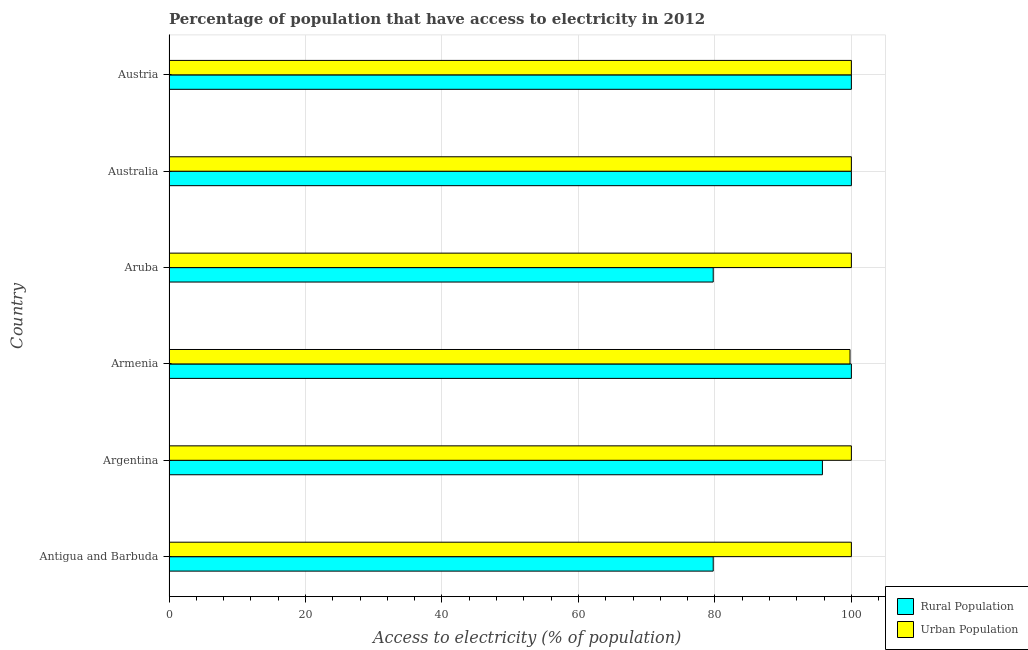Are the number of bars per tick equal to the number of legend labels?
Offer a very short reply. Yes. Are the number of bars on each tick of the Y-axis equal?
Keep it short and to the point. Yes. How many bars are there on the 1st tick from the bottom?
Make the answer very short. 2. What is the label of the 6th group of bars from the top?
Provide a short and direct response. Antigua and Barbuda. In how many cases, is the number of bars for a given country not equal to the number of legend labels?
Your answer should be very brief. 0. What is the percentage of rural population having access to electricity in Antigua and Barbuda?
Provide a succinct answer. 79.75. Across all countries, what is the maximum percentage of urban population having access to electricity?
Your response must be concise. 100. Across all countries, what is the minimum percentage of urban population having access to electricity?
Offer a very short reply. 99.8. In which country was the percentage of rural population having access to electricity maximum?
Provide a succinct answer. Armenia. In which country was the percentage of urban population having access to electricity minimum?
Offer a very short reply. Armenia. What is the total percentage of rural population having access to electricity in the graph?
Provide a short and direct response. 555.26. What is the difference between the percentage of rural population having access to electricity in Antigua and Barbuda and that in Aruba?
Provide a succinct answer. 0. What is the difference between the percentage of urban population having access to electricity in Argentina and the percentage of rural population having access to electricity in Austria?
Give a very brief answer. 0. What is the average percentage of urban population having access to electricity per country?
Offer a terse response. 99.97. What is the difference between the percentage of urban population having access to electricity and percentage of rural population having access to electricity in Antigua and Barbuda?
Your answer should be very brief. 20.25. In how many countries, is the percentage of urban population having access to electricity greater than 40 %?
Offer a terse response. 6. What is the ratio of the percentage of rural population having access to electricity in Aruba to that in Australia?
Provide a succinct answer. 0.8. Is the difference between the percentage of rural population having access to electricity in Aruba and Australia greater than the difference between the percentage of urban population having access to electricity in Aruba and Australia?
Your answer should be compact. No. What is the difference between the highest and the second highest percentage of urban population having access to electricity?
Your answer should be compact. 0. What is the difference between the highest and the lowest percentage of urban population having access to electricity?
Provide a succinct answer. 0.2. What does the 1st bar from the top in Austria represents?
Give a very brief answer. Urban Population. What does the 1st bar from the bottom in Austria represents?
Make the answer very short. Rural Population. Are all the bars in the graph horizontal?
Your answer should be very brief. Yes. What is the difference between two consecutive major ticks on the X-axis?
Provide a succinct answer. 20. Does the graph contain grids?
Your answer should be very brief. Yes. Where does the legend appear in the graph?
Give a very brief answer. Bottom right. How are the legend labels stacked?
Offer a very short reply. Vertical. What is the title of the graph?
Keep it short and to the point. Percentage of population that have access to electricity in 2012. Does "Males" appear as one of the legend labels in the graph?
Provide a succinct answer. No. What is the label or title of the X-axis?
Your answer should be compact. Access to electricity (% of population). What is the label or title of the Y-axis?
Provide a succinct answer. Country. What is the Access to electricity (% of population) in Rural Population in Antigua and Barbuda?
Your answer should be compact. 79.75. What is the Access to electricity (% of population) in Rural Population in Argentina?
Offer a very short reply. 95.75. What is the Access to electricity (% of population) of Urban Population in Armenia?
Your response must be concise. 99.8. What is the Access to electricity (% of population) of Rural Population in Aruba?
Offer a very short reply. 79.75. What is the Access to electricity (% of population) in Urban Population in Aruba?
Keep it short and to the point. 100. What is the Access to electricity (% of population) of Urban Population in Australia?
Make the answer very short. 100. What is the Access to electricity (% of population) of Rural Population in Austria?
Provide a succinct answer. 100. What is the Access to electricity (% of population) in Urban Population in Austria?
Your answer should be compact. 100. Across all countries, what is the minimum Access to electricity (% of population) in Rural Population?
Provide a succinct answer. 79.75. Across all countries, what is the minimum Access to electricity (% of population) of Urban Population?
Provide a succinct answer. 99.8. What is the total Access to electricity (% of population) of Rural Population in the graph?
Offer a terse response. 555.26. What is the total Access to electricity (% of population) in Urban Population in the graph?
Keep it short and to the point. 599.8. What is the difference between the Access to electricity (% of population) of Urban Population in Antigua and Barbuda and that in Argentina?
Provide a short and direct response. 0. What is the difference between the Access to electricity (% of population) of Rural Population in Antigua and Barbuda and that in Armenia?
Your response must be concise. -20.25. What is the difference between the Access to electricity (% of population) in Urban Population in Antigua and Barbuda and that in Aruba?
Provide a succinct answer. 0. What is the difference between the Access to electricity (% of population) of Rural Population in Antigua and Barbuda and that in Australia?
Provide a short and direct response. -20.25. What is the difference between the Access to electricity (% of population) of Urban Population in Antigua and Barbuda and that in Australia?
Give a very brief answer. 0. What is the difference between the Access to electricity (% of population) of Rural Population in Antigua and Barbuda and that in Austria?
Your response must be concise. -20.25. What is the difference between the Access to electricity (% of population) of Urban Population in Antigua and Barbuda and that in Austria?
Offer a terse response. 0. What is the difference between the Access to electricity (% of population) in Rural Population in Argentina and that in Armenia?
Your response must be concise. -4.25. What is the difference between the Access to electricity (% of population) in Urban Population in Argentina and that in Armenia?
Provide a short and direct response. 0.2. What is the difference between the Access to electricity (% of population) in Rural Population in Argentina and that in Australia?
Provide a short and direct response. -4.25. What is the difference between the Access to electricity (% of population) in Urban Population in Argentina and that in Australia?
Offer a terse response. 0. What is the difference between the Access to electricity (% of population) in Rural Population in Argentina and that in Austria?
Your answer should be very brief. -4.25. What is the difference between the Access to electricity (% of population) of Rural Population in Armenia and that in Aruba?
Provide a succinct answer. 20.25. What is the difference between the Access to electricity (% of population) of Urban Population in Armenia and that in Aruba?
Your response must be concise. -0.2. What is the difference between the Access to electricity (% of population) in Rural Population in Armenia and that in Australia?
Keep it short and to the point. 0. What is the difference between the Access to electricity (% of population) in Urban Population in Armenia and that in Australia?
Provide a short and direct response. -0.2. What is the difference between the Access to electricity (% of population) of Rural Population in Armenia and that in Austria?
Your answer should be very brief. 0. What is the difference between the Access to electricity (% of population) of Urban Population in Armenia and that in Austria?
Your answer should be very brief. -0.2. What is the difference between the Access to electricity (% of population) of Rural Population in Aruba and that in Australia?
Provide a short and direct response. -20.25. What is the difference between the Access to electricity (% of population) in Rural Population in Aruba and that in Austria?
Ensure brevity in your answer.  -20.25. What is the difference between the Access to electricity (% of population) of Rural Population in Antigua and Barbuda and the Access to electricity (% of population) of Urban Population in Argentina?
Offer a very short reply. -20.25. What is the difference between the Access to electricity (% of population) of Rural Population in Antigua and Barbuda and the Access to electricity (% of population) of Urban Population in Armenia?
Your answer should be very brief. -20.05. What is the difference between the Access to electricity (% of population) in Rural Population in Antigua and Barbuda and the Access to electricity (% of population) in Urban Population in Aruba?
Your answer should be very brief. -20.25. What is the difference between the Access to electricity (% of population) in Rural Population in Antigua and Barbuda and the Access to electricity (% of population) in Urban Population in Australia?
Your response must be concise. -20.25. What is the difference between the Access to electricity (% of population) in Rural Population in Antigua and Barbuda and the Access to electricity (% of population) in Urban Population in Austria?
Offer a very short reply. -20.25. What is the difference between the Access to electricity (% of population) in Rural Population in Argentina and the Access to electricity (% of population) in Urban Population in Armenia?
Offer a very short reply. -4.05. What is the difference between the Access to electricity (% of population) of Rural Population in Argentina and the Access to electricity (% of population) of Urban Population in Aruba?
Provide a succinct answer. -4.25. What is the difference between the Access to electricity (% of population) in Rural Population in Argentina and the Access to electricity (% of population) in Urban Population in Australia?
Offer a very short reply. -4.25. What is the difference between the Access to electricity (% of population) in Rural Population in Argentina and the Access to electricity (% of population) in Urban Population in Austria?
Offer a very short reply. -4.25. What is the difference between the Access to electricity (% of population) of Rural Population in Armenia and the Access to electricity (% of population) of Urban Population in Australia?
Provide a short and direct response. 0. What is the difference between the Access to electricity (% of population) of Rural Population in Aruba and the Access to electricity (% of population) of Urban Population in Australia?
Your answer should be very brief. -20.25. What is the difference between the Access to electricity (% of population) of Rural Population in Aruba and the Access to electricity (% of population) of Urban Population in Austria?
Your answer should be compact. -20.25. What is the difference between the Access to electricity (% of population) of Rural Population in Australia and the Access to electricity (% of population) of Urban Population in Austria?
Give a very brief answer. 0. What is the average Access to electricity (% of population) of Rural Population per country?
Give a very brief answer. 92.54. What is the average Access to electricity (% of population) of Urban Population per country?
Keep it short and to the point. 99.97. What is the difference between the Access to electricity (% of population) in Rural Population and Access to electricity (% of population) in Urban Population in Antigua and Barbuda?
Your answer should be very brief. -20.25. What is the difference between the Access to electricity (% of population) of Rural Population and Access to electricity (% of population) of Urban Population in Argentina?
Provide a succinct answer. -4.25. What is the difference between the Access to electricity (% of population) of Rural Population and Access to electricity (% of population) of Urban Population in Armenia?
Give a very brief answer. 0.2. What is the difference between the Access to electricity (% of population) of Rural Population and Access to electricity (% of population) of Urban Population in Aruba?
Keep it short and to the point. -20.25. What is the difference between the Access to electricity (% of population) of Rural Population and Access to electricity (% of population) of Urban Population in Australia?
Your response must be concise. 0. What is the ratio of the Access to electricity (% of population) in Rural Population in Antigua and Barbuda to that in Argentina?
Offer a terse response. 0.83. What is the ratio of the Access to electricity (% of population) in Rural Population in Antigua and Barbuda to that in Armenia?
Your answer should be very brief. 0.8. What is the ratio of the Access to electricity (% of population) in Urban Population in Antigua and Barbuda to that in Armenia?
Your answer should be very brief. 1. What is the ratio of the Access to electricity (% of population) in Rural Population in Antigua and Barbuda to that in Australia?
Keep it short and to the point. 0.8. What is the ratio of the Access to electricity (% of population) of Rural Population in Antigua and Barbuda to that in Austria?
Make the answer very short. 0.8. What is the ratio of the Access to electricity (% of population) in Urban Population in Antigua and Barbuda to that in Austria?
Provide a short and direct response. 1. What is the ratio of the Access to electricity (% of population) of Rural Population in Argentina to that in Armenia?
Ensure brevity in your answer.  0.96. What is the ratio of the Access to electricity (% of population) of Urban Population in Argentina to that in Armenia?
Offer a terse response. 1. What is the ratio of the Access to electricity (% of population) in Rural Population in Argentina to that in Aruba?
Keep it short and to the point. 1.2. What is the ratio of the Access to electricity (% of population) in Rural Population in Argentina to that in Australia?
Your answer should be compact. 0.96. What is the ratio of the Access to electricity (% of population) in Urban Population in Argentina to that in Australia?
Provide a short and direct response. 1. What is the ratio of the Access to electricity (% of population) in Rural Population in Argentina to that in Austria?
Offer a very short reply. 0.96. What is the ratio of the Access to electricity (% of population) in Urban Population in Argentina to that in Austria?
Offer a very short reply. 1. What is the ratio of the Access to electricity (% of population) in Rural Population in Armenia to that in Aruba?
Your answer should be very brief. 1.25. What is the ratio of the Access to electricity (% of population) of Rural Population in Armenia to that in Australia?
Your answer should be very brief. 1. What is the ratio of the Access to electricity (% of population) of Urban Population in Armenia to that in Australia?
Offer a terse response. 1. What is the ratio of the Access to electricity (% of population) in Rural Population in Armenia to that in Austria?
Offer a very short reply. 1. What is the ratio of the Access to electricity (% of population) in Urban Population in Armenia to that in Austria?
Your response must be concise. 1. What is the ratio of the Access to electricity (% of population) in Rural Population in Aruba to that in Australia?
Provide a succinct answer. 0.8. What is the ratio of the Access to electricity (% of population) in Rural Population in Aruba to that in Austria?
Ensure brevity in your answer.  0.8. What is the ratio of the Access to electricity (% of population) in Urban Population in Aruba to that in Austria?
Provide a short and direct response. 1. What is the ratio of the Access to electricity (% of population) of Urban Population in Australia to that in Austria?
Ensure brevity in your answer.  1. What is the difference between the highest and the second highest Access to electricity (% of population) in Urban Population?
Offer a terse response. 0. What is the difference between the highest and the lowest Access to electricity (% of population) of Rural Population?
Your answer should be compact. 20.25. What is the difference between the highest and the lowest Access to electricity (% of population) of Urban Population?
Ensure brevity in your answer.  0.2. 